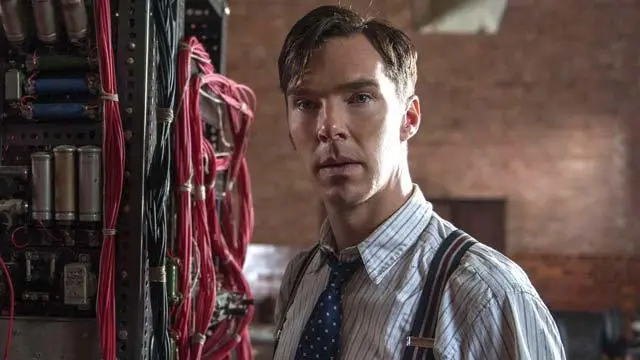What are the key elements in this picture?
 In this image, we see the renowned actor Benedict Cumberbatch, portraying the character of Alan Turing in the film "The Imitation Game". He is standing in front of a large machine filled with an array of red wires and silver cylinders, a testament to the technological era the film is set in. Dressed in a crisp white shirt, a blue tie, and striped suspenders, he embodies the quintessential scientist of the time. His face wears a serious expression, eyes looking off to the side, lost in thought - a fitting portrayal of Turing's intense focus and dedication. The image captures not just a scene, but a moment of history brought to life through cinema. 